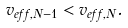<formula> <loc_0><loc_0><loc_500><loc_500>v _ { e f f , N - 1 } < v _ { e f f , N } .</formula> 